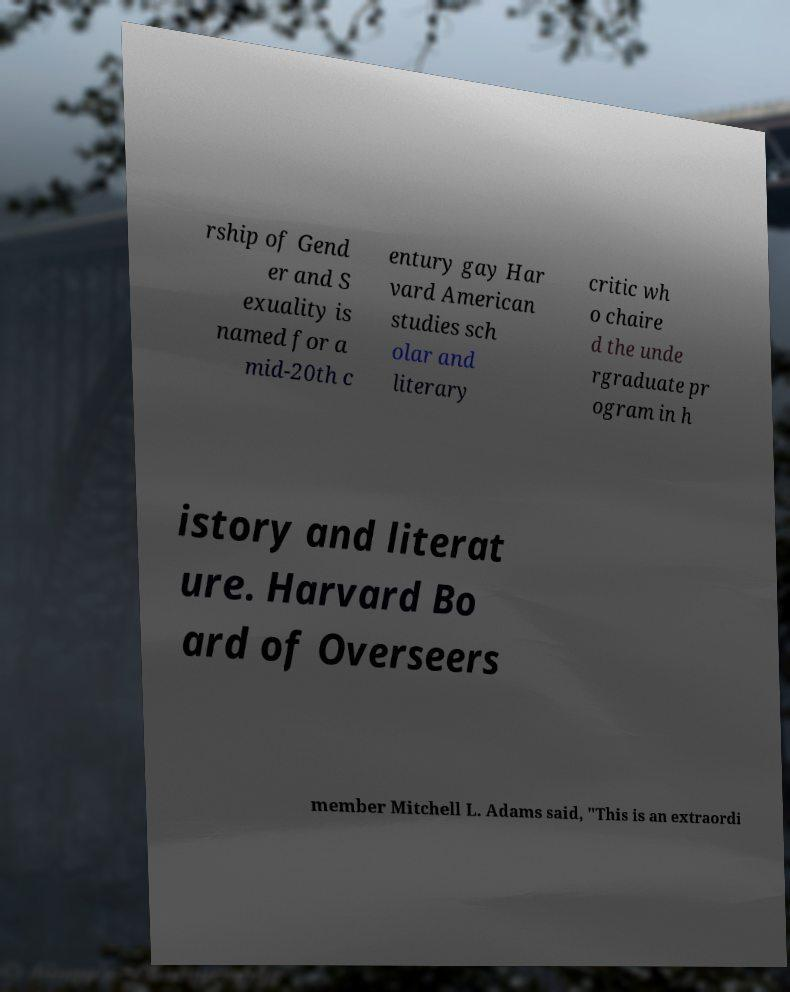There's text embedded in this image that I need extracted. Can you transcribe it verbatim? rship of Gend er and S exuality is named for a mid-20th c entury gay Har vard American studies sch olar and literary critic wh o chaire d the unde rgraduate pr ogram in h istory and literat ure. Harvard Bo ard of Overseers member Mitchell L. Adams said, "This is an extraordi 